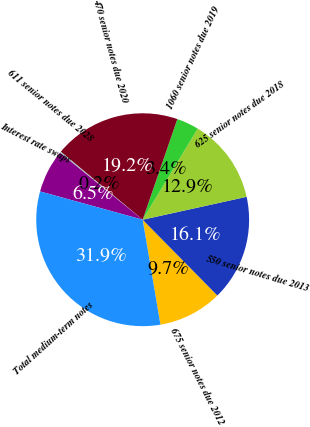Convert chart. <chart><loc_0><loc_0><loc_500><loc_500><pie_chart><fcel>675 senior notes due 2012<fcel>550 senior notes due 2013<fcel>625 senior notes due 2018<fcel>1060 senior notes due 2019<fcel>470 senior notes due 2020<fcel>611 senior notes due 2028<fcel>Interest rate swaps<fcel>Total medium-term notes<nl><fcel>9.72%<fcel>16.07%<fcel>12.9%<fcel>3.37%<fcel>19.25%<fcel>0.2%<fcel>6.55%<fcel>31.95%<nl></chart> 